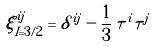<formula> <loc_0><loc_0><loc_500><loc_500>\xi ^ { i j } _ { I = 3 / 2 } = \delta ^ { i j } - \frac { 1 } { 3 } \, \tau ^ { i } \tau ^ { j }</formula> 